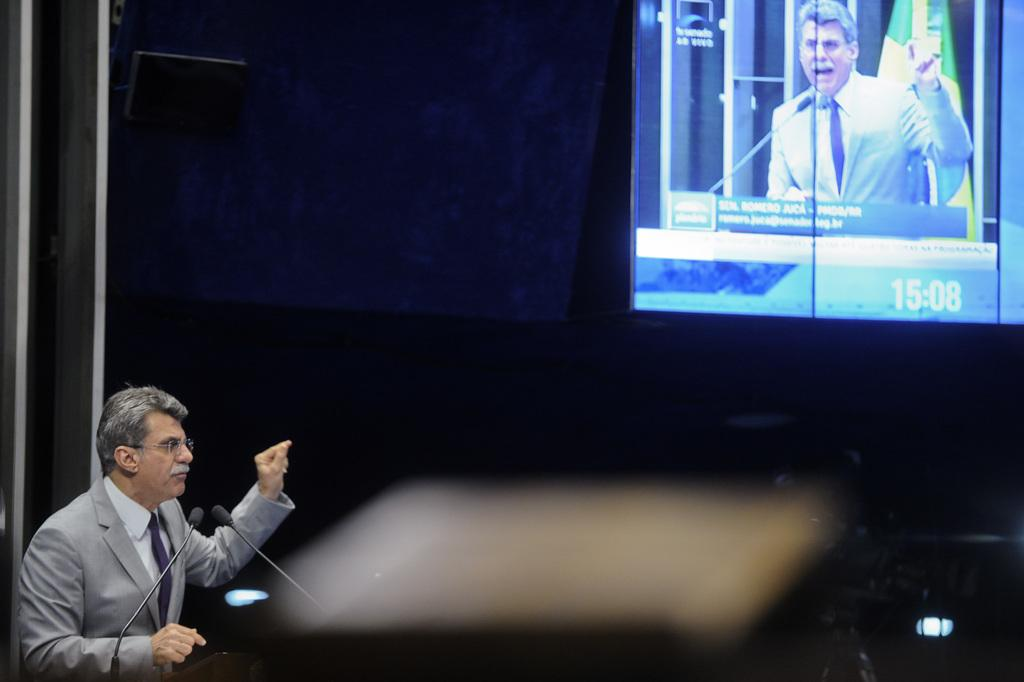<image>
Render a clear and concise summary of the photo. A grey suited Senator speaks in government chambers while a monitor televises him to audience 